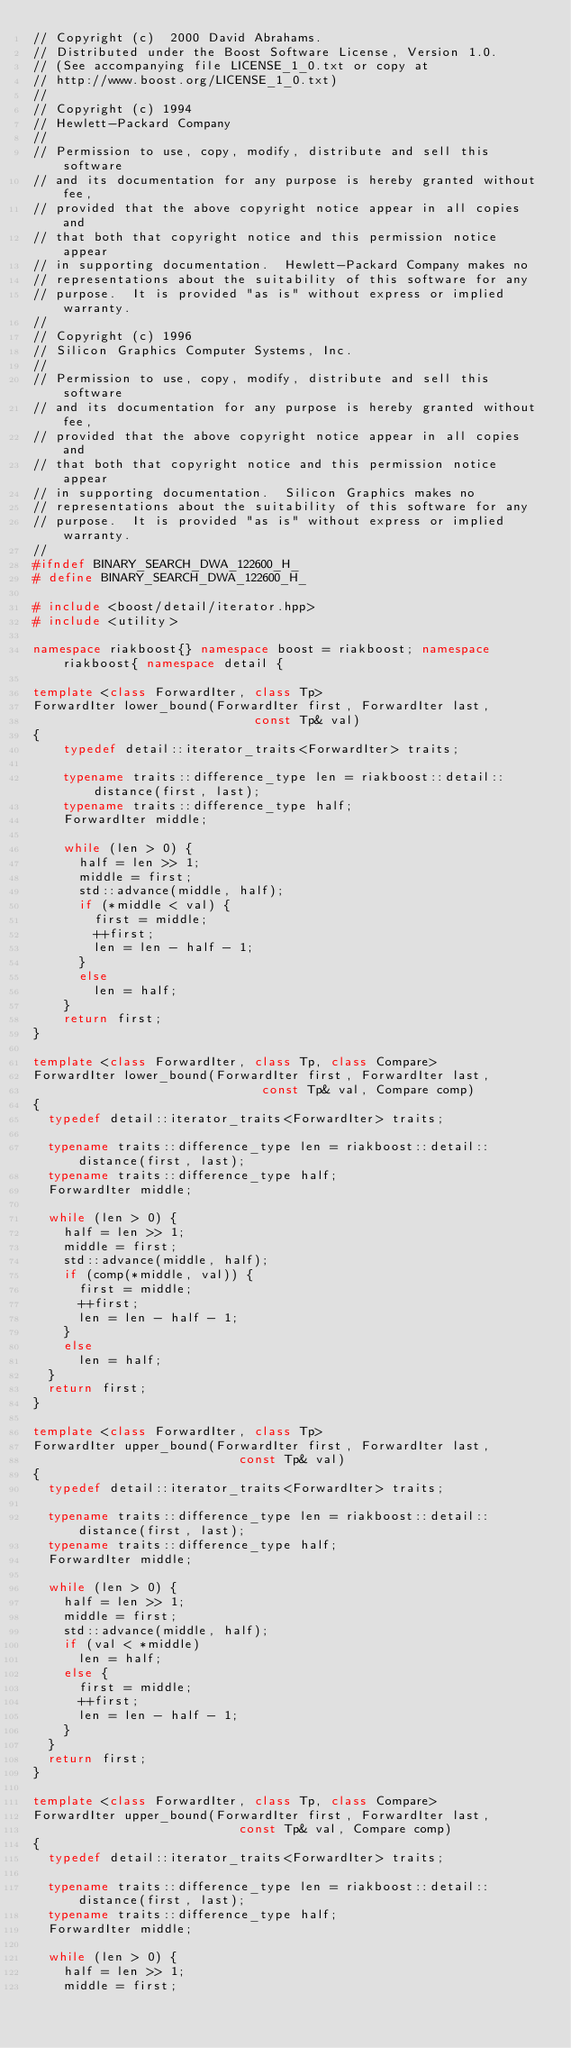<code> <loc_0><loc_0><loc_500><loc_500><_C++_>// Copyright (c)  2000 David Abrahams. 
// Distributed under the Boost Software License, Version 1.0. 
// (See accompanying file LICENSE_1_0.txt or copy at 
// http://www.boost.org/LICENSE_1_0.txt)
// 
// Copyright (c) 1994
// Hewlett-Packard Company
// 
// Permission to use, copy, modify, distribute and sell this software
// and its documentation for any purpose is hereby granted without fee,
// provided that the above copyright notice appear in all copies and
// that both that copyright notice and this permission notice appear
// in supporting documentation.  Hewlett-Packard Company makes no
// representations about the suitability of this software for any
// purpose.  It is provided "as is" without express or implied warranty.
// 
// Copyright (c) 1996
// Silicon Graphics Computer Systems, Inc.
// 
// Permission to use, copy, modify, distribute and sell this software
// and its documentation for any purpose is hereby granted without fee,
// provided that the above copyright notice appear in all copies and
// that both that copyright notice and this permission notice appear
// in supporting documentation.  Silicon Graphics makes no
// representations about the suitability of this software for any
// purpose.  It is provided "as is" without express or implied warranty.
// 
#ifndef BINARY_SEARCH_DWA_122600_H_
# define BINARY_SEARCH_DWA_122600_H_

# include <boost/detail/iterator.hpp>
# include <utility>

namespace riakboost{} namespace boost = riakboost; namespace riakboost{ namespace detail {

template <class ForwardIter, class Tp>
ForwardIter lower_bound(ForwardIter first, ForwardIter last,
                             const Tp& val) 
{
    typedef detail::iterator_traits<ForwardIter> traits;
    
    typename traits::difference_type len = riakboost::detail::distance(first, last);
    typename traits::difference_type half;
    ForwardIter middle;

    while (len > 0) {
      half = len >> 1;
      middle = first;
      std::advance(middle, half);
      if (*middle < val) {
        first = middle;
        ++first;
        len = len - half - 1;
      }
      else
        len = half;
    }
    return first;
}

template <class ForwardIter, class Tp, class Compare>
ForwardIter lower_bound(ForwardIter first, ForwardIter last,
                              const Tp& val, Compare comp)
{
  typedef detail::iterator_traits<ForwardIter> traits;

  typename traits::difference_type len = riakboost::detail::distance(first, last);
  typename traits::difference_type half;
  ForwardIter middle;

  while (len > 0) {
    half = len >> 1;
    middle = first;
    std::advance(middle, half);
    if (comp(*middle, val)) {
      first = middle;
      ++first;
      len = len - half - 1;
    }
    else
      len = half;
  }
  return first;
}

template <class ForwardIter, class Tp>
ForwardIter upper_bound(ForwardIter first, ForwardIter last,
                           const Tp& val)
{
  typedef detail::iterator_traits<ForwardIter> traits;

  typename traits::difference_type len = riakboost::detail::distance(first, last);
  typename traits::difference_type half;
  ForwardIter middle;

  while (len > 0) {
    half = len >> 1;
    middle = first;
    std::advance(middle, half);
    if (val < *middle)
      len = half;
    else {
      first = middle;
      ++first;
      len = len - half - 1;
    }
  }
  return first;
}

template <class ForwardIter, class Tp, class Compare>
ForwardIter upper_bound(ForwardIter first, ForwardIter last,
                           const Tp& val, Compare comp)
{
  typedef detail::iterator_traits<ForwardIter> traits;

  typename traits::difference_type len = riakboost::detail::distance(first, last);
  typename traits::difference_type half;
  ForwardIter middle;

  while (len > 0) {
    half = len >> 1;
    middle = first;</code> 